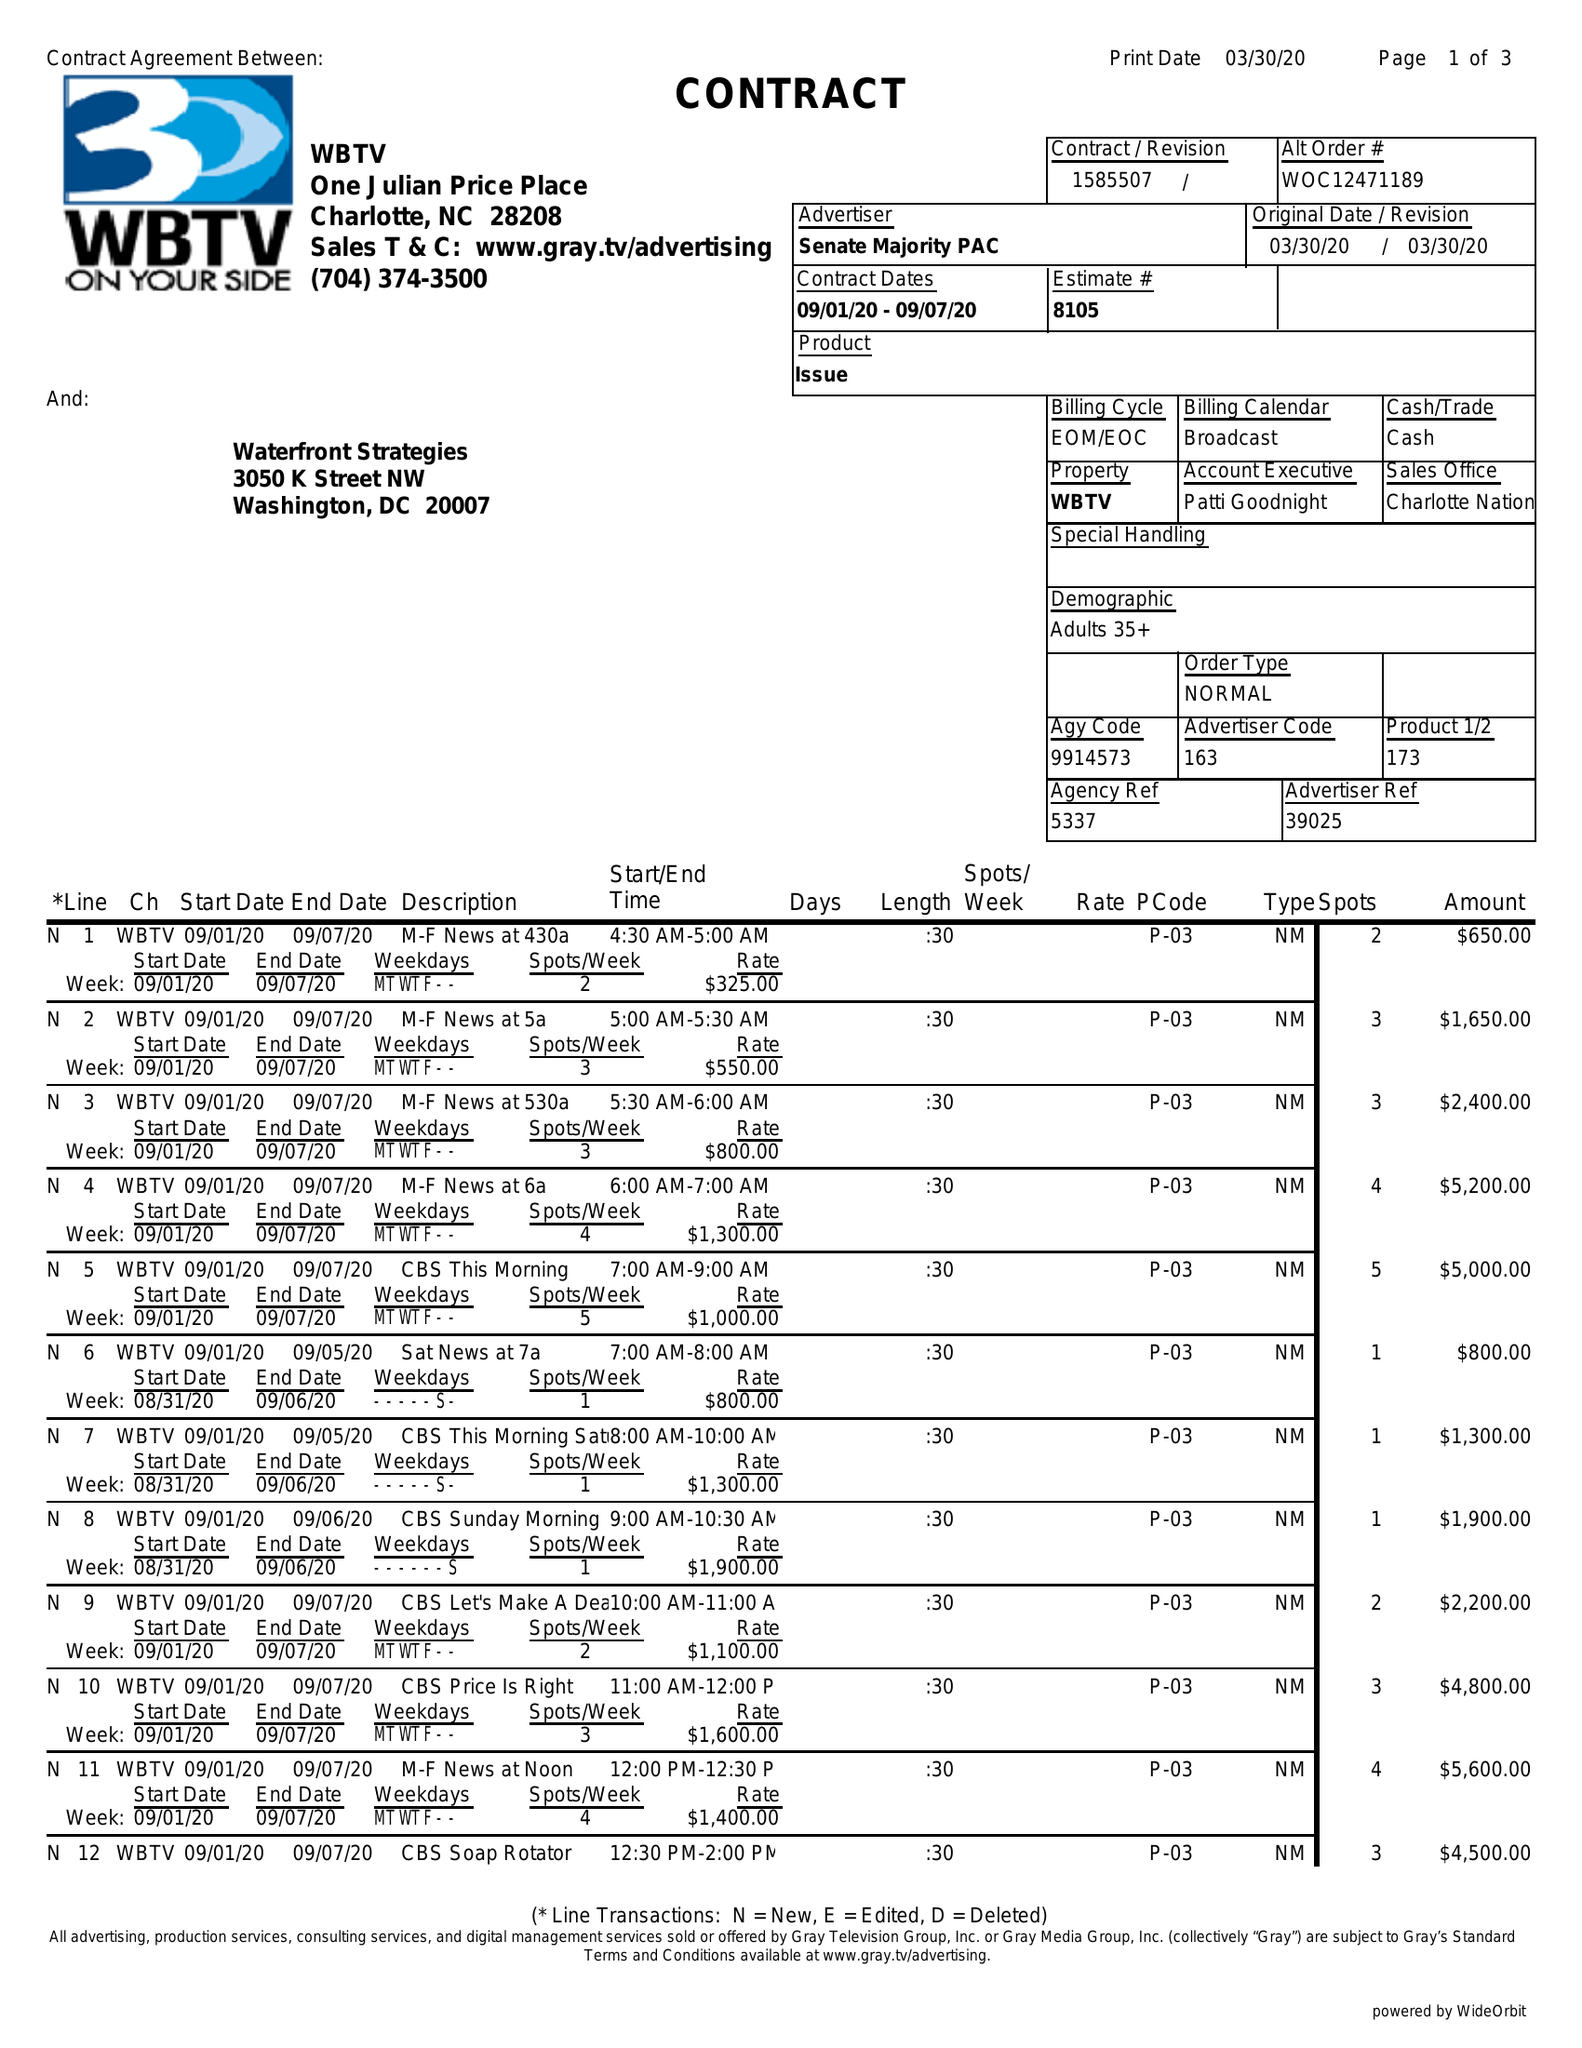What is the value for the flight_from?
Answer the question using a single word or phrase. 09/01/20 